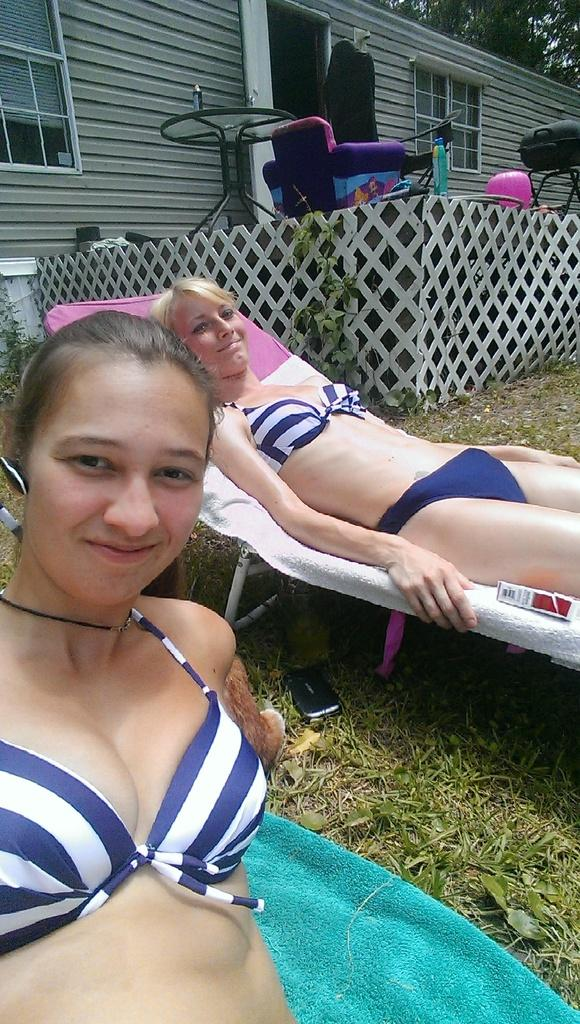How many women are present in the image? There are two women in the image. What is the position of one of the women in the image? There is a woman laying on the bed. What type of structure can be seen in the background of the image? There is a house visible in the image. What type of plant is present in the image? There is a tree in the image. What type of treatment is the woman receiving in the image? There is no indication in the image that the woman is receiving any treatment. What type of rhythm can be heard in the image? There is no sound or music present in the image, so it's not possible to determine any rhythm. 